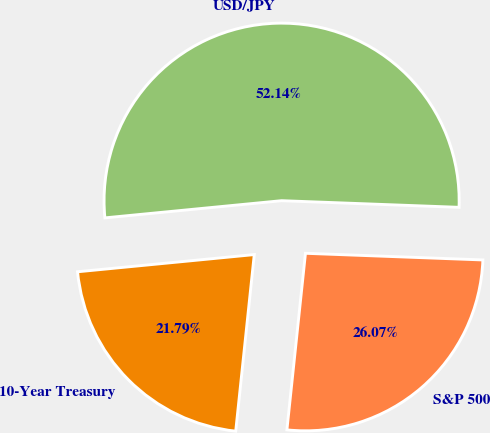Convert chart to OTSL. <chart><loc_0><loc_0><loc_500><loc_500><pie_chart><fcel>10-Year Treasury<fcel>S&P 500<fcel>USD/JPY<nl><fcel>21.79%<fcel>26.07%<fcel>52.14%<nl></chart> 